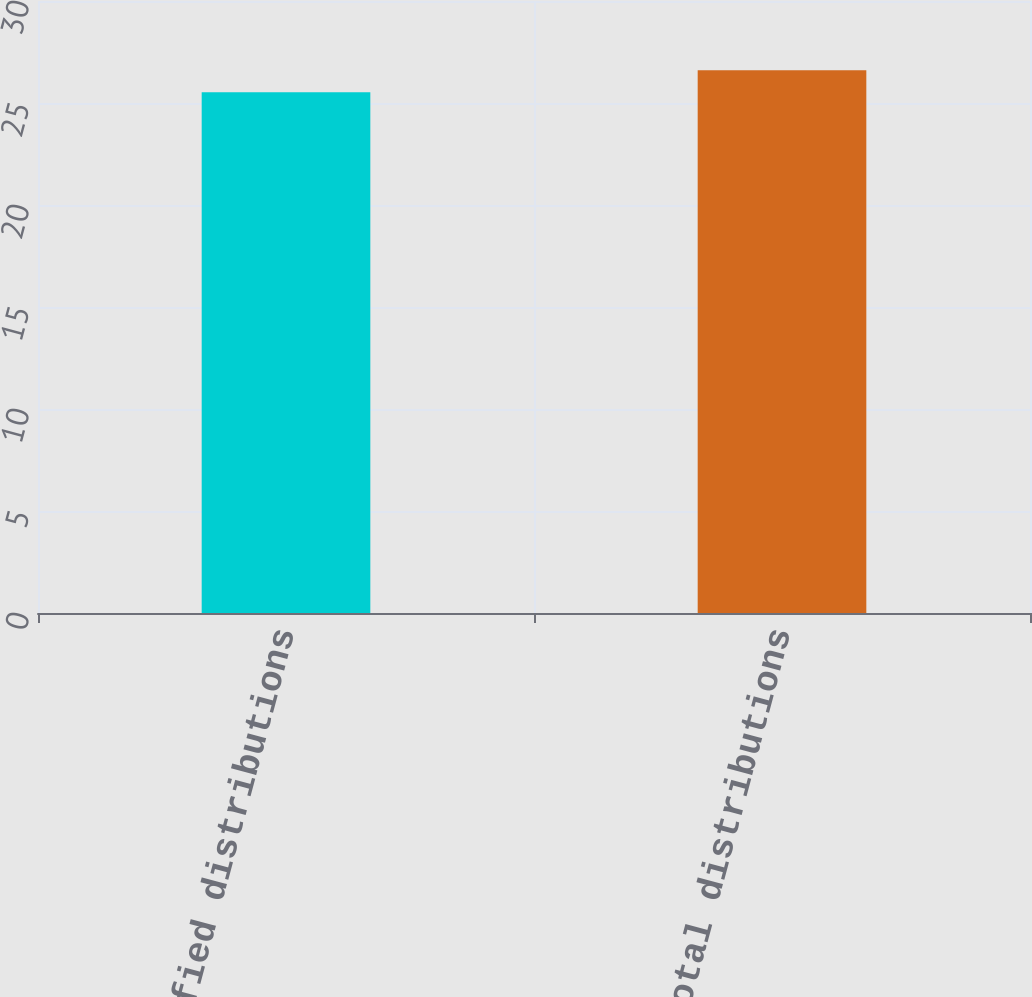Convert chart to OTSL. <chart><loc_0><loc_0><loc_500><loc_500><bar_chart><fcel>Qualified distributions<fcel>Total distributions<nl><fcel>25.53<fcel>26.61<nl></chart> 